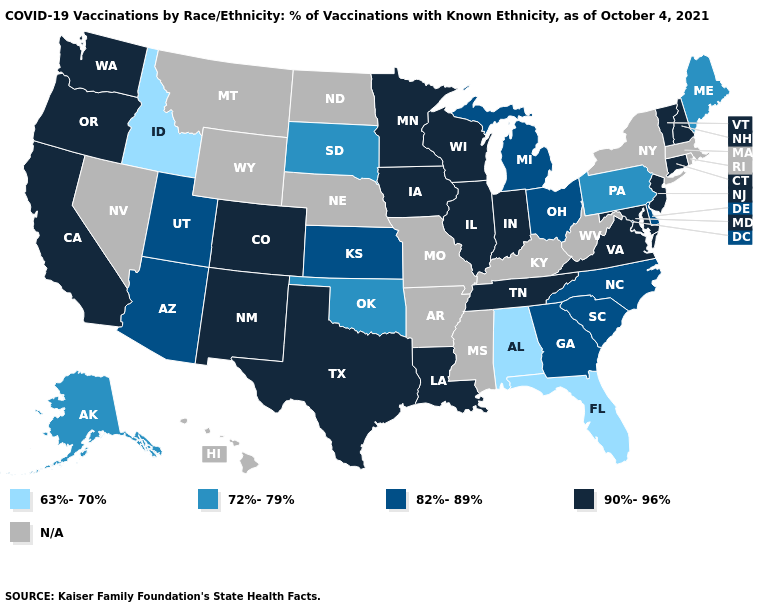Is the legend a continuous bar?
Short answer required. No. What is the highest value in the Northeast ?
Short answer required. 90%-96%. Name the states that have a value in the range 63%-70%?
Give a very brief answer. Alabama, Florida, Idaho. Which states have the highest value in the USA?
Give a very brief answer. California, Colorado, Connecticut, Illinois, Indiana, Iowa, Louisiana, Maryland, Minnesota, New Hampshire, New Jersey, New Mexico, Oregon, Tennessee, Texas, Vermont, Virginia, Washington, Wisconsin. What is the value of Florida?
Answer briefly. 63%-70%. Which states have the highest value in the USA?
Write a very short answer. California, Colorado, Connecticut, Illinois, Indiana, Iowa, Louisiana, Maryland, Minnesota, New Hampshire, New Jersey, New Mexico, Oregon, Tennessee, Texas, Vermont, Virginia, Washington, Wisconsin. What is the value of South Carolina?
Answer briefly. 82%-89%. Which states have the lowest value in the USA?
Write a very short answer. Alabama, Florida, Idaho. Name the states that have a value in the range 82%-89%?
Concise answer only. Arizona, Delaware, Georgia, Kansas, Michigan, North Carolina, Ohio, South Carolina, Utah. Name the states that have a value in the range 82%-89%?
Concise answer only. Arizona, Delaware, Georgia, Kansas, Michigan, North Carolina, Ohio, South Carolina, Utah. Does the first symbol in the legend represent the smallest category?
Short answer required. Yes. Does the first symbol in the legend represent the smallest category?
Give a very brief answer. Yes. 